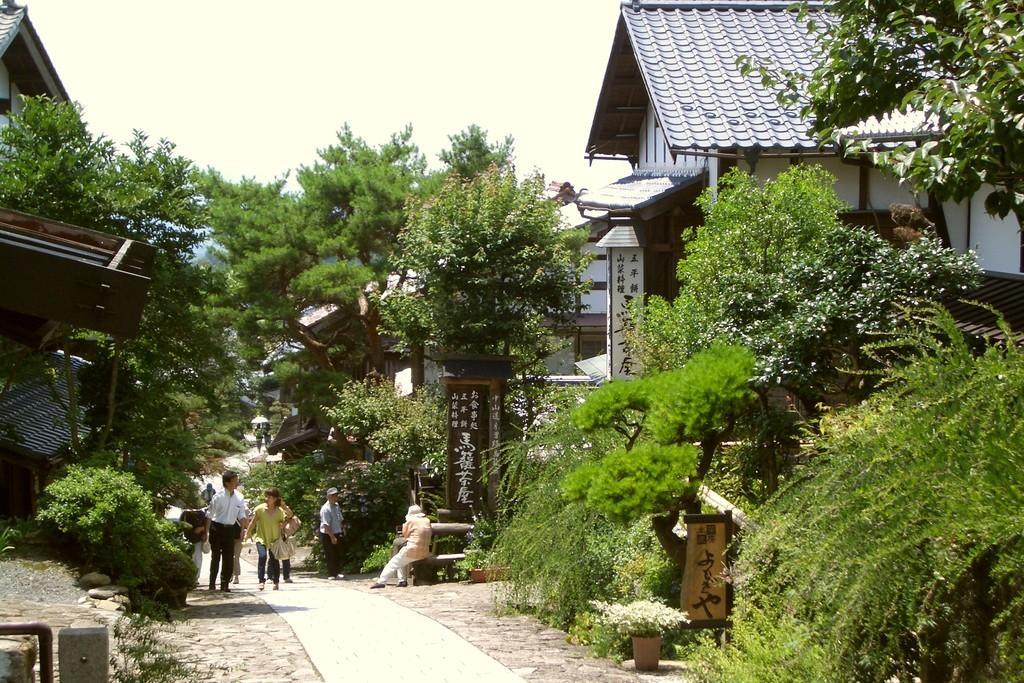Could you give a brief overview of what you see in this image? This picture shows trees and few buildings and we see few people walking and a woman seated and we see a cloudy sky and a board with some text on it and few plants in the pots. 